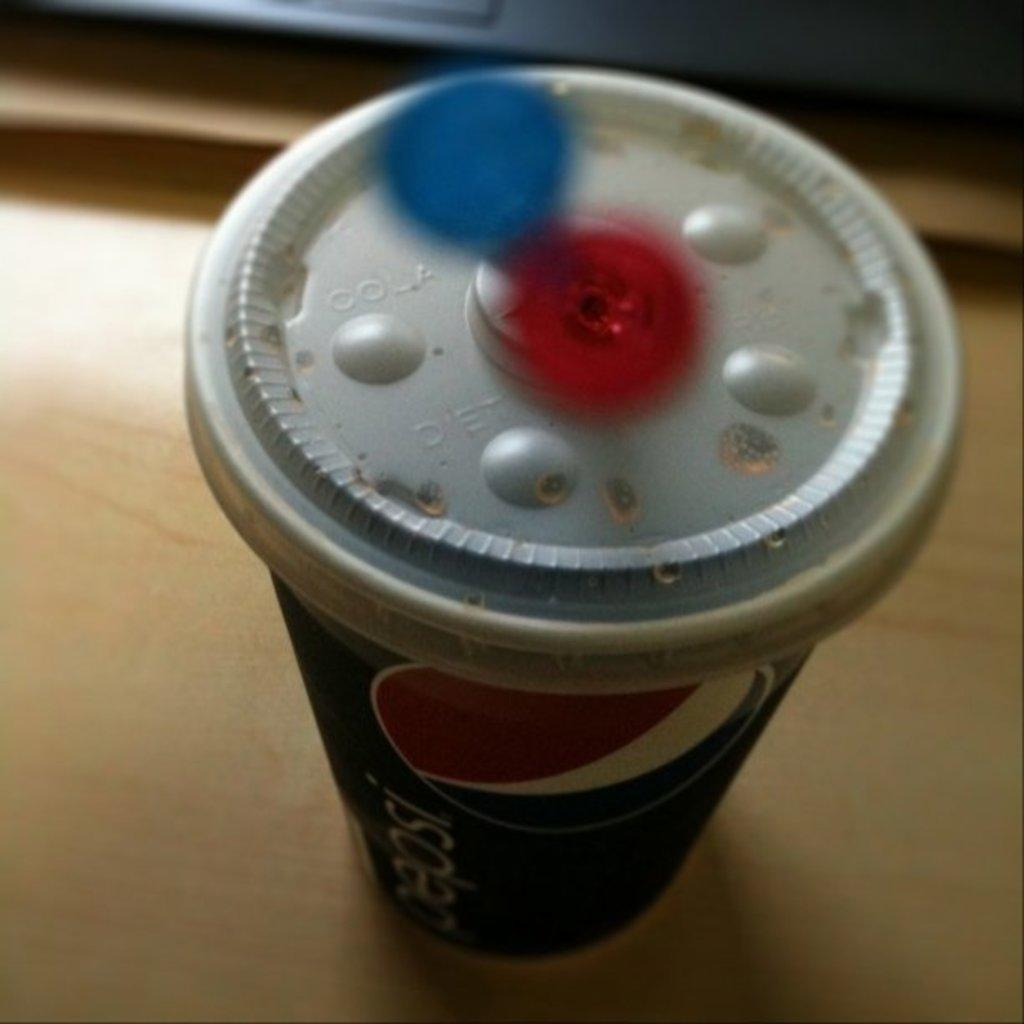<image>
Relay a brief, clear account of the picture shown. The side of the cup has the name Pepsi on it. 